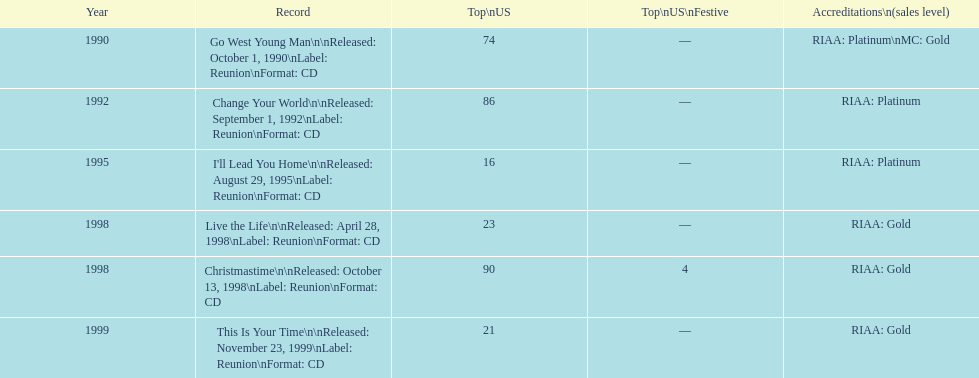What is the earliest year mentioned? 1990. 